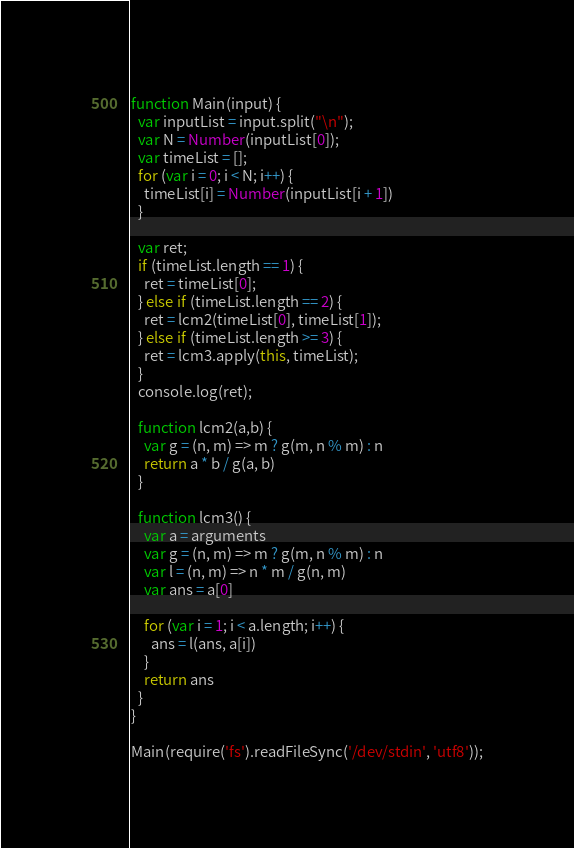<code> <loc_0><loc_0><loc_500><loc_500><_JavaScript_>function Main(input) {
  var inputList = input.split("\n");
  var N = Number(inputList[0]);
  var timeList = [];
  for (var i = 0; i < N; i++) {
    timeList[i] = Number(inputList[i + 1])
  }

  var ret;
  if (timeList.length == 1) {
    ret = timeList[0];
  } else if (timeList.length == 2) {
    ret = lcm2(timeList[0], timeList[1]);
  } else if (timeList.length >= 3) {
    ret = lcm3.apply(this, timeList);
  }
  console.log(ret);

  function lcm2(a,b) {
    var g = (n, m) => m ? g(m, n % m) : n
    return a * b / g(a, b)
  }

  function lcm3() {
    var a = arguments
    var g = (n, m) => m ? g(m, n % m) : n
    var l = (n, m) => n * m / g(n, m)
    var ans = a[0]

    for (var i = 1; i < a.length; i++) {
      ans = l(ans, a[i])
    }
    return ans
  }
}

Main(require('fs').readFileSync('/dev/stdin', 'utf8'));</code> 